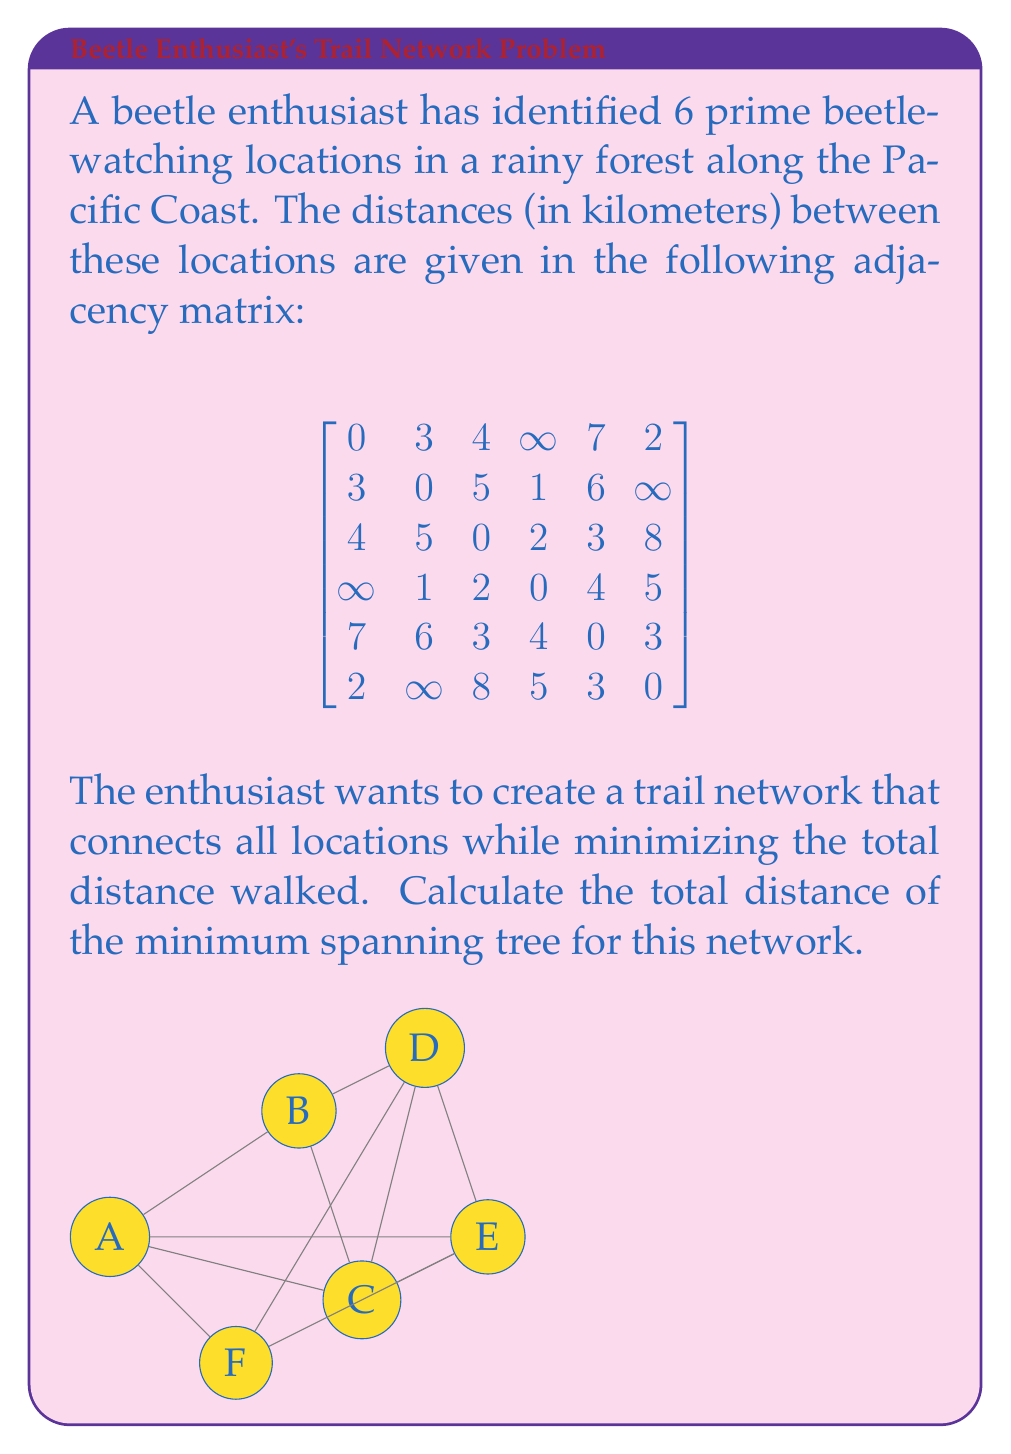Can you solve this math problem? To find the minimum spanning tree, we can use Kruskal's algorithm:

1) Sort all edges by weight (distance) in ascending order:
   B-D (1), A-F (2), C-D (2), C-E (3), E-F (3), A-B (3), A-C (4), D-E (4), B-C (5), D-F (5), B-E (6), A-E (7)

2) Start with an empty set of edges and add edges one by one, skipping those that would create a cycle:

   - Add B-D (1)
   - Add A-F (2)
   - Add C-D (2)
   - Add C-E (3)
   - Skip E-F (3) as it would create a cycle
   - Skip A-B (3) as it would create a cycle
   - Skip A-C (4) as it would create a cycle
   - Skip D-E (4) as it would create a cycle

3) We now have 5 edges, which is correct for a minimum spanning tree of 6 vertices.

4) The selected edges are:
   B-D (1), A-F (2), C-D (2), C-E (3)

5) Calculate the total distance:
   $1 + 2 + 2 + 3 = 8$

Therefore, the total distance of the minimum spanning tree is 8 kilometers.
Answer: 8 kilometers 